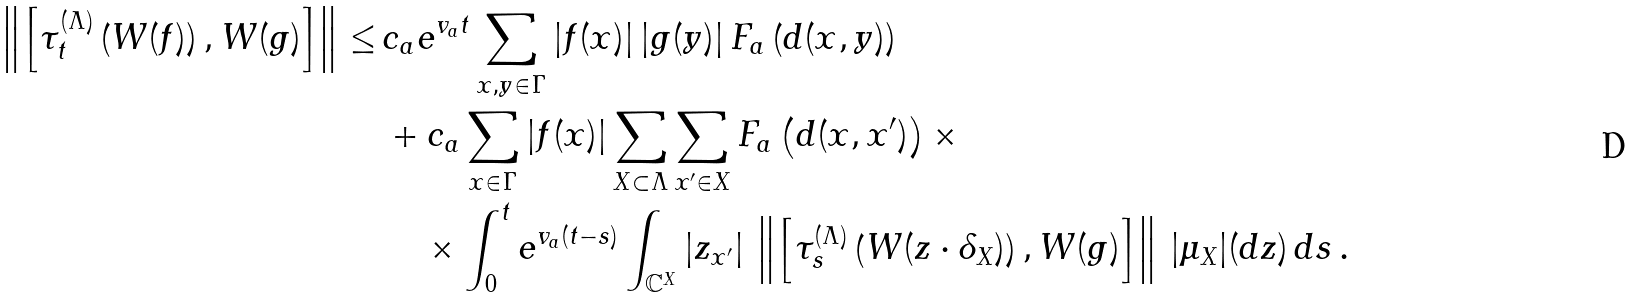Convert formula to latex. <formula><loc_0><loc_0><loc_500><loc_500>\left \| \left [ \tau _ { t } ^ { ( \Lambda ) } \left ( W ( f ) \right ) , W ( g ) \right ] \right \| \leq \, & c _ { a } e ^ { v _ { a } t } \sum _ { x , y \in \Gamma } | f ( x ) | \, | g ( y ) | \, F _ { a } \left ( d ( x , y ) \right ) \\ & + c _ { a } \sum _ { x \in \Gamma } | f ( x ) | \sum _ { X \subset \Lambda } \sum _ { x ^ { \prime } \in X } F _ { a } \left ( d ( x , x ^ { \prime } ) \right ) \times \\ & \quad \times \int _ { 0 } ^ { t } e ^ { v _ { a } ( t - s ) } \int _ { \mathbb { C } ^ { X } } | z _ { x ^ { \prime } } | \, \left \| \left [ \tau _ { s } ^ { ( \Lambda ) } \left ( W ( z \cdot \delta _ { X } ) \right ) , W ( g ) \right ] \right \| \, | \mu _ { X } | ( d z ) \, d s \, .</formula> 